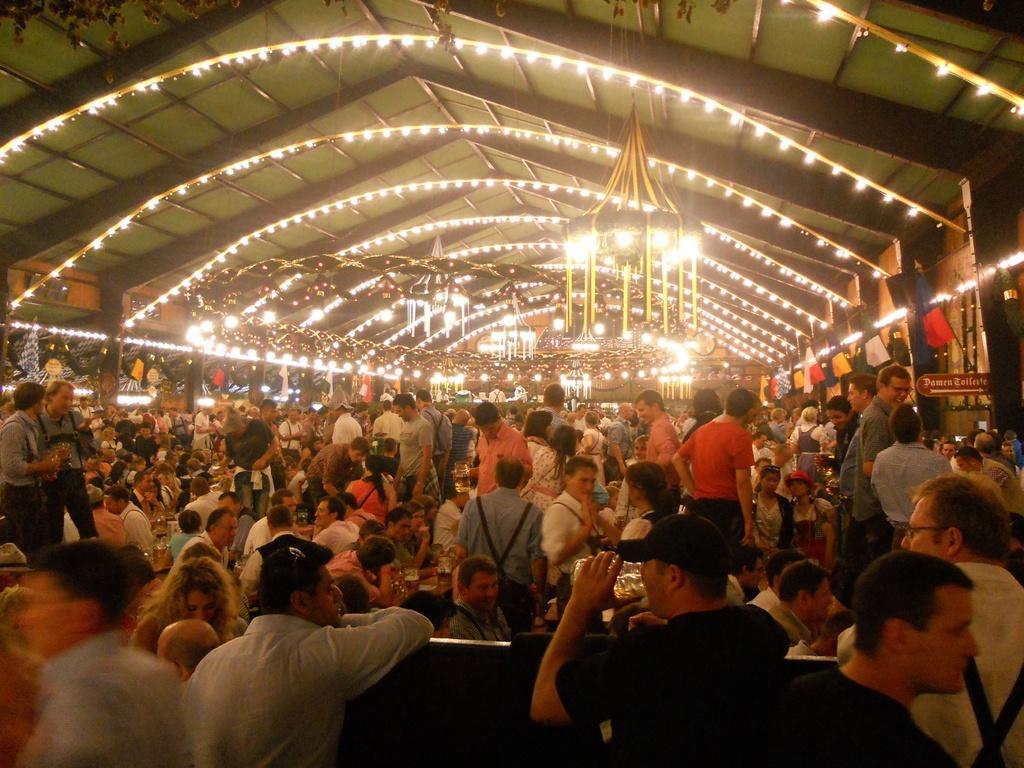How would you summarize this image in a sentence or two? In this picture, we can see group of people, few people are standing and few people are sitting on the chair in front of the bench and few people are walking. On the bench, we can see some bottles. On top there is a roof with few lights. 